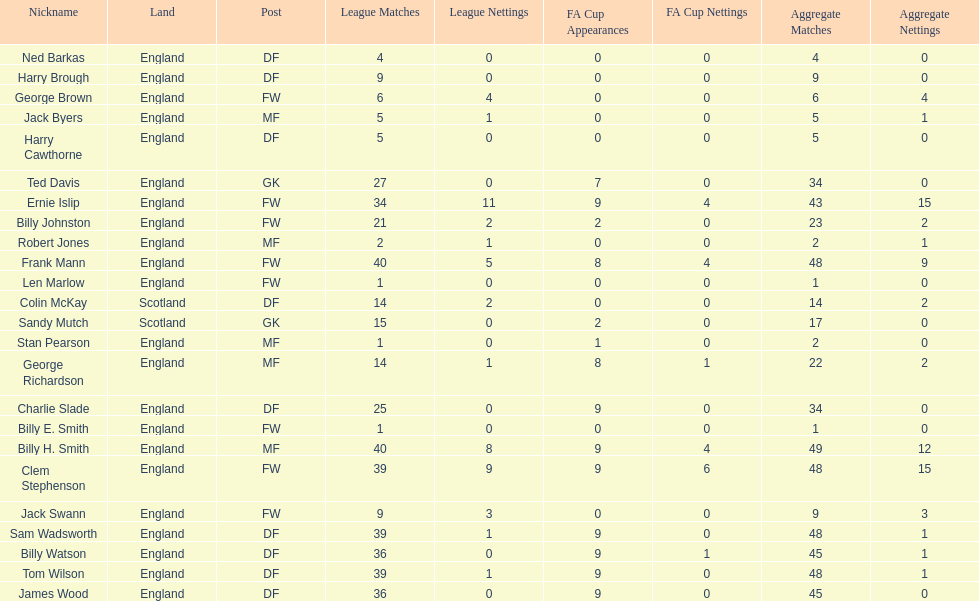What are the number of league apps ted davis has? 27. 